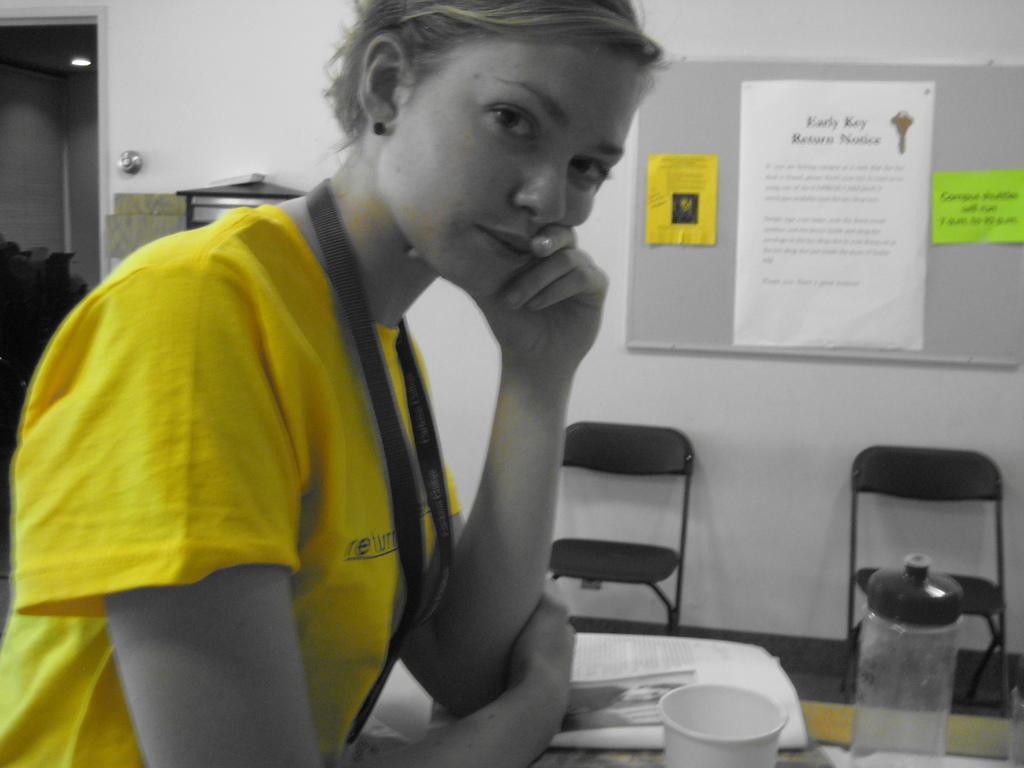What kind of restore notice in on the bulletin board?
Your response must be concise. Early key. 